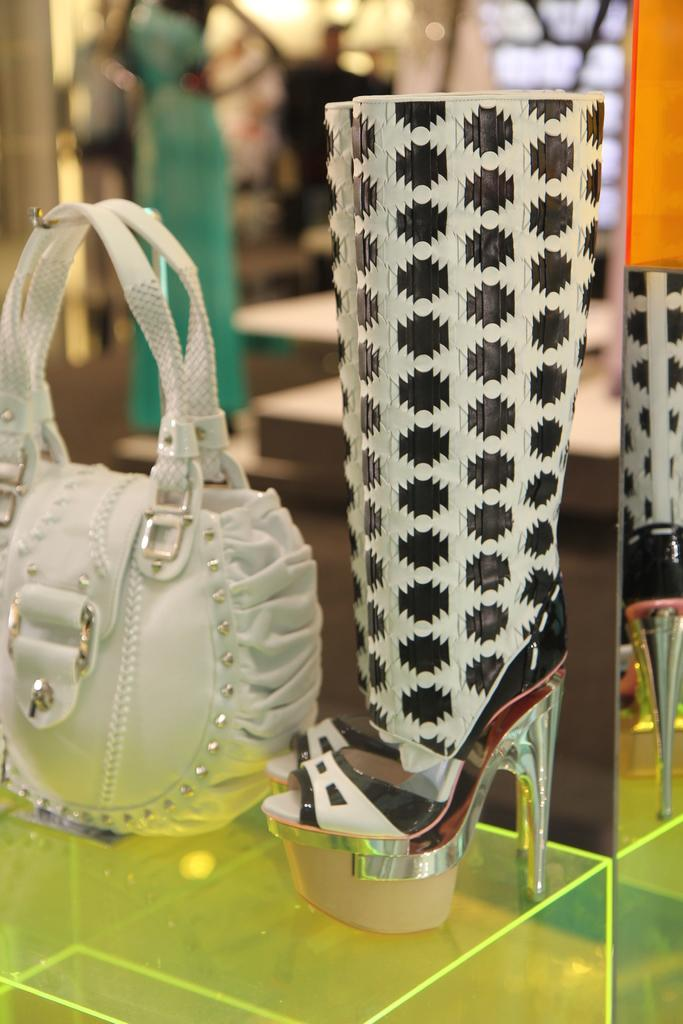What type of accessory is visible in the image? There is a handbag in the image. What type of footwear is also visible in the image? There are sandals in the image. Where are the handbag and sandals located? The handbag and sandals are on a table. What type of food is being prepared on the table in the image? There is no food visible in the image; it only features a handbag and sandals on a table. 